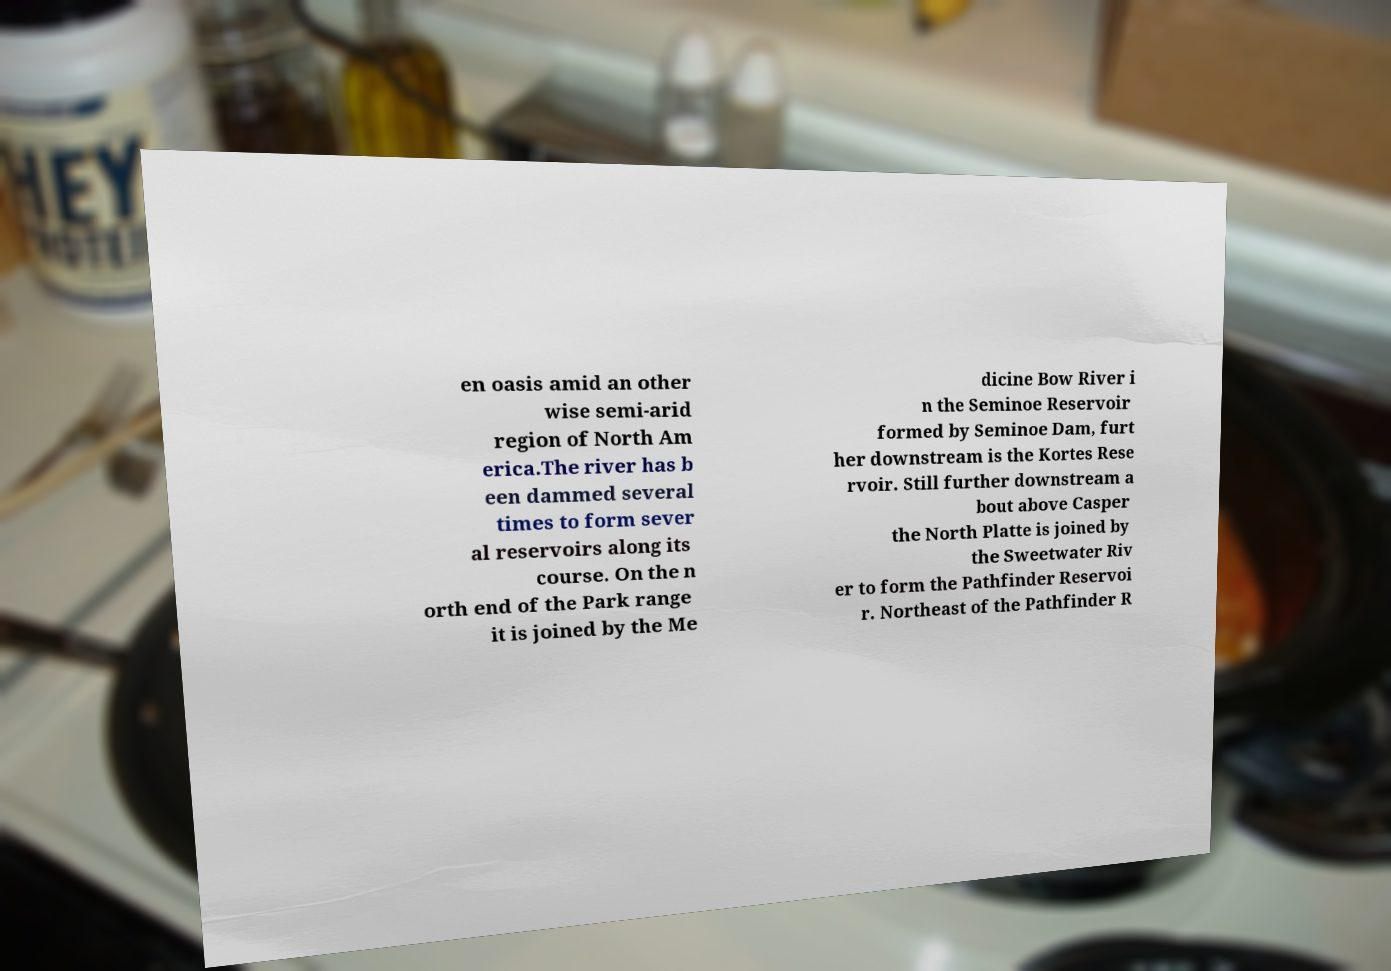Please identify and transcribe the text found in this image. en oasis amid an other wise semi-arid region of North Am erica.The river has b een dammed several times to form sever al reservoirs along its course. On the n orth end of the Park range it is joined by the Me dicine Bow River i n the Seminoe Reservoir formed by Seminoe Dam, furt her downstream is the Kortes Rese rvoir. Still further downstream a bout above Casper the North Platte is joined by the Sweetwater Riv er to form the Pathfinder Reservoi r. Northeast of the Pathfinder R 